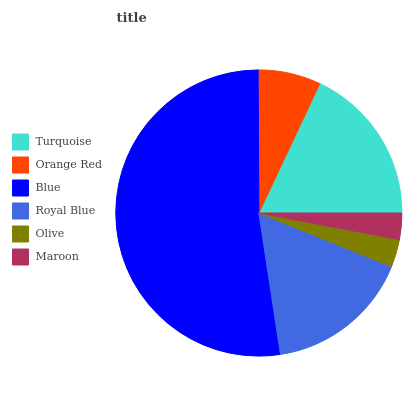Is Maroon the minimum?
Answer yes or no. Yes. Is Blue the maximum?
Answer yes or no. Yes. Is Orange Red the minimum?
Answer yes or no. No. Is Orange Red the maximum?
Answer yes or no. No. Is Turquoise greater than Orange Red?
Answer yes or no. Yes. Is Orange Red less than Turquoise?
Answer yes or no. Yes. Is Orange Red greater than Turquoise?
Answer yes or no. No. Is Turquoise less than Orange Red?
Answer yes or no. No. Is Royal Blue the high median?
Answer yes or no. Yes. Is Orange Red the low median?
Answer yes or no. Yes. Is Orange Red the high median?
Answer yes or no. No. Is Blue the low median?
Answer yes or no. No. 